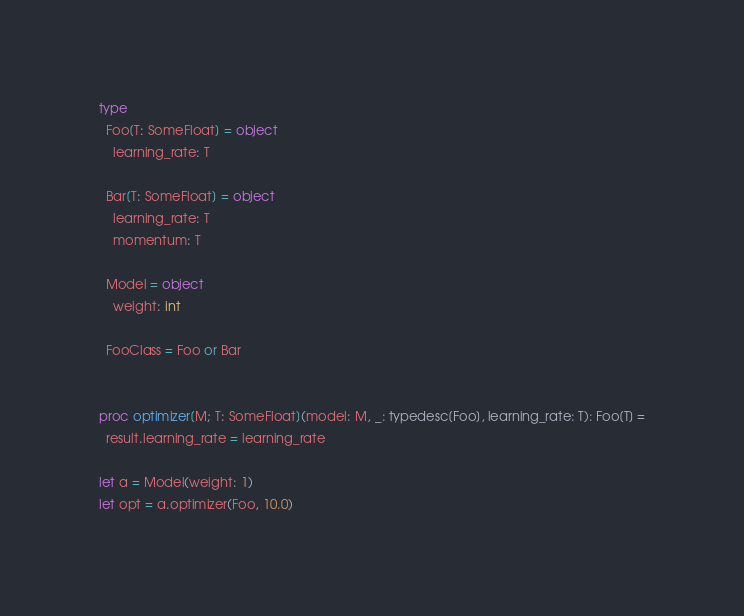Convert code to text. <code><loc_0><loc_0><loc_500><loc_500><_Nim_>type
  Foo[T: SomeFloat] = object
    learning_rate: T

  Bar[T: SomeFloat] = object
    learning_rate: T
    momentum: T

  Model = object
    weight: int

  FooClass = Foo or Bar


proc optimizer[M; T: SomeFloat](model: M, _: typedesc[Foo], learning_rate: T): Foo[T] =
  result.learning_rate = learning_rate

let a = Model(weight: 1)
let opt = a.optimizer(Foo, 10.0)
</code> 